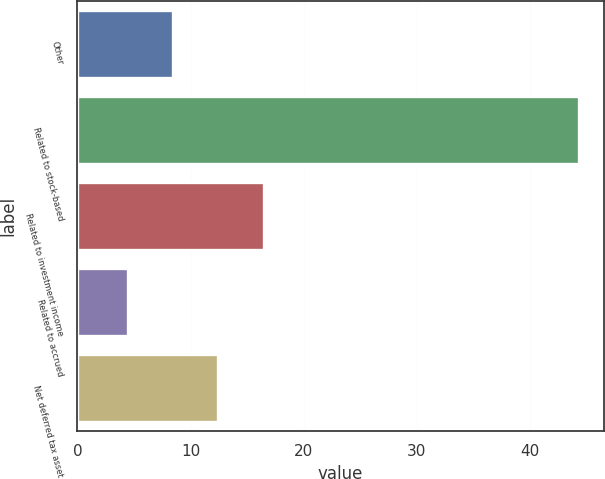Convert chart to OTSL. <chart><loc_0><loc_0><loc_500><loc_500><bar_chart><fcel>Other<fcel>Related to stock-based<fcel>Related to investment income<fcel>Related to accrued<fcel>Net deferred tax asset<nl><fcel>8.48<fcel>44.3<fcel>16.44<fcel>4.5<fcel>12.46<nl></chart> 